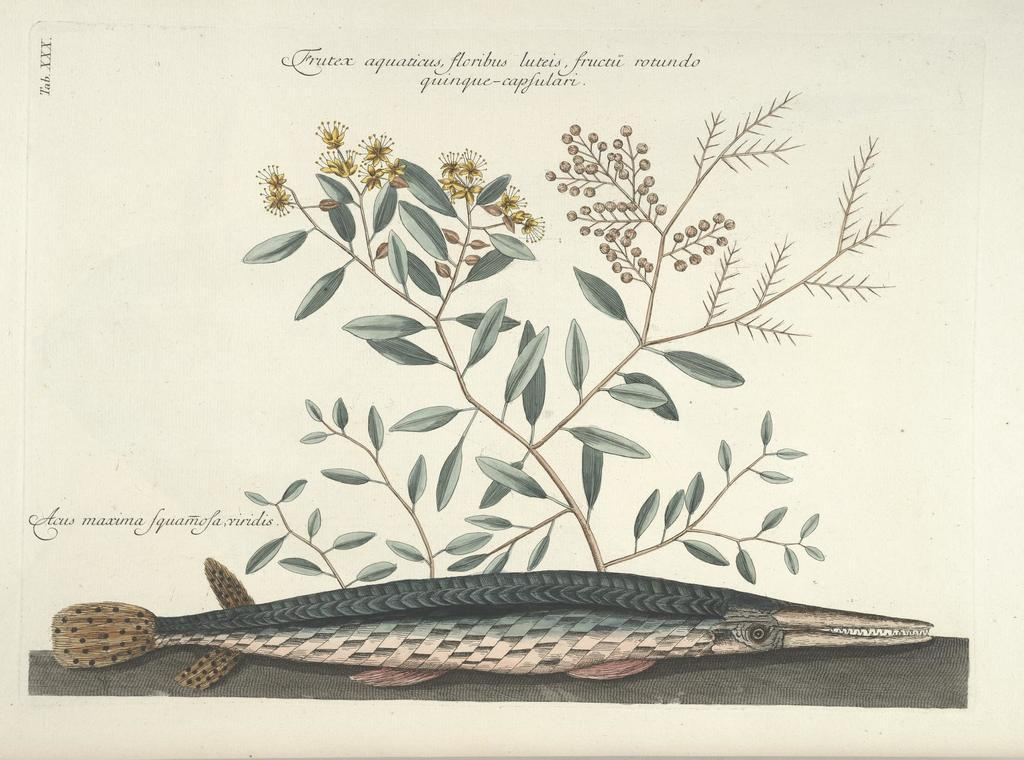What is depicted on the poster in the image? There is a plant poster in the image. What other object can be seen in the image besides the poster? There is a fish at the bottom side of the image. What is the aftermath of the event depicted in the image? There is no event depicted in the image, as it only features a plant poster and a fish. How does the memory of the fish affect the plant poster in the image? There is no memory or emotional connection between the fish and the plant poster in the image, as they are separate objects. 